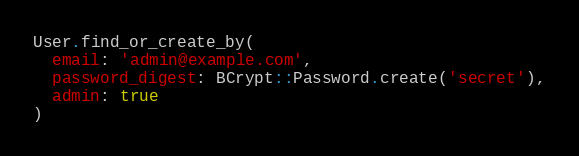Convert code to text. <code><loc_0><loc_0><loc_500><loc_500><_Ruby_>User.find_or_create_by(
  email: 'admin@example.com',
  password_digest: BCrypt::Password.create('secret'),
  admin: true
)
</code> 